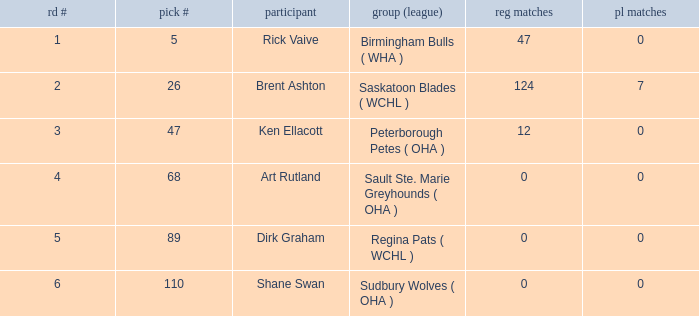How many rounds exist for picks under 5? 0.0. 